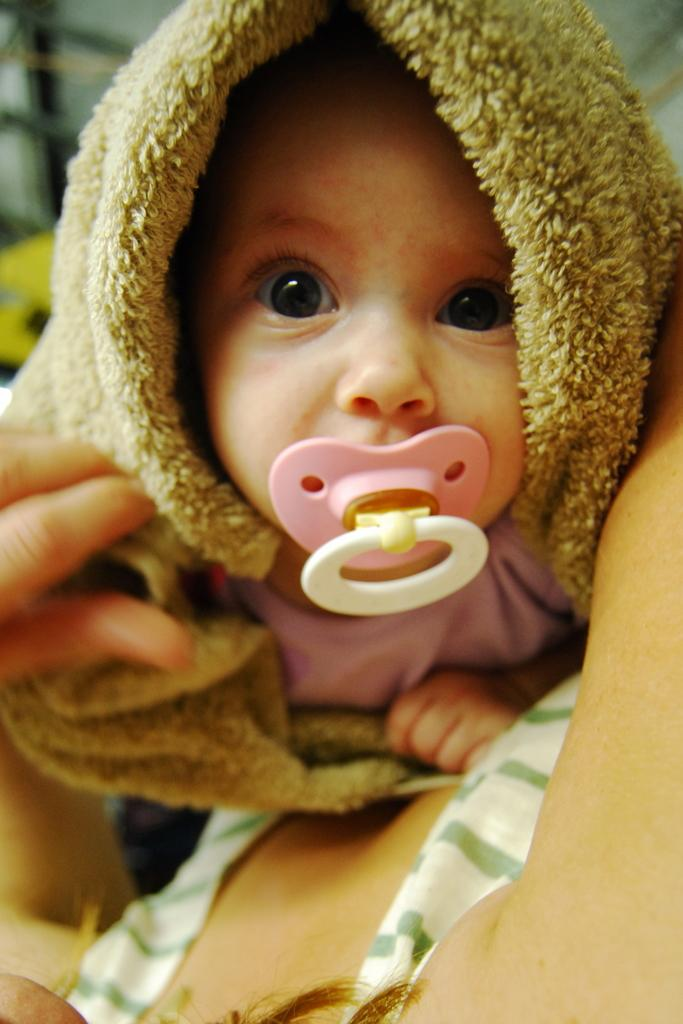What is the main subject of the picture? The main subject of the picture is a small baby. What is the baby holding in the picture? The baby is holding a pink color pacifier in the mouth. What is the baby doing in the picture? The baby is looking into the camera. What is on the top of the baby's head? There is a brown color cloth on the top of the baby's head. What type of crime is being committed in the picture? There is no crime being committed in the picture; it features a small baby holding a pacifier and looking into the camera. What time of day is depicted in the picture? The time of day is not mentioned or depicted in the picture. 